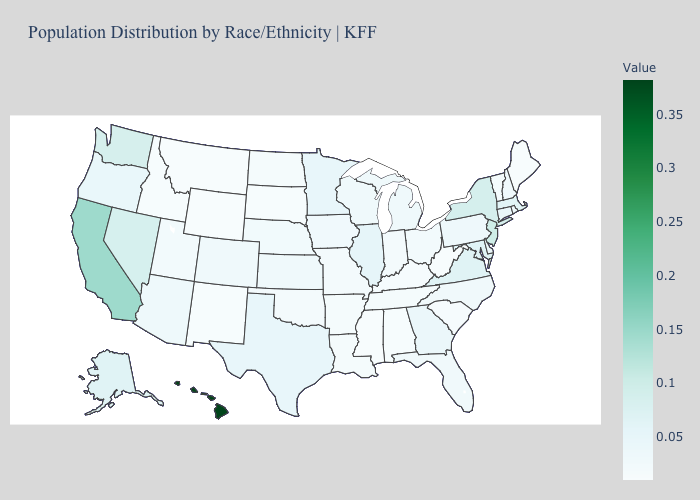Does Oregon have the highest value in the USA?
Write a very short answer. No. Among the states that border Washington , which have the highest value?
Concise answer only. Oregon. 